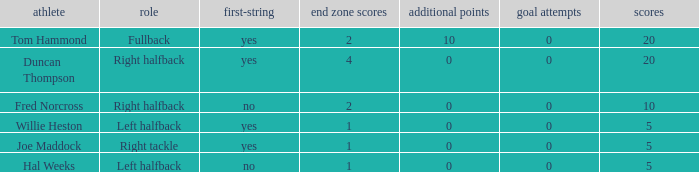How many field goals did duncan thompson have? 0.0. 